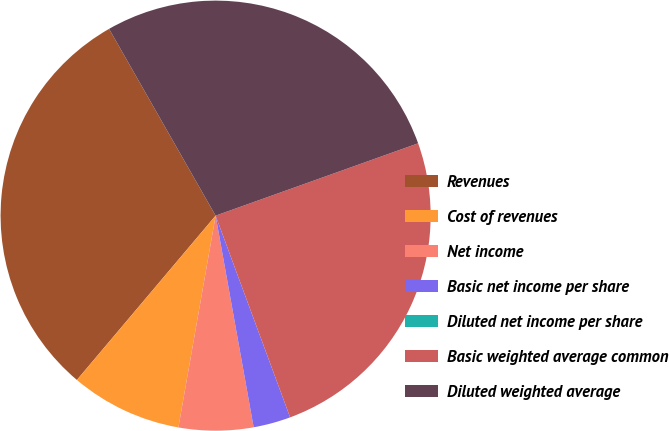<chart> <loc_0><loc_0><loc_500><loc_500><pie_chart><fcel>Revenues<fcel>Cost of revenues<fcel>Net income<fcel>Basic net income per share<fcel>Diluted net income per share<fcel>Basic weighted average common<fcel>Diluted weighted average<nl><fcel>30.59%<fcel>8.39%<fcel>5.6%<fcel>2.8%<fcel>0.0%<fcel>24.83%<fcel>27.79%<nl></chart> 